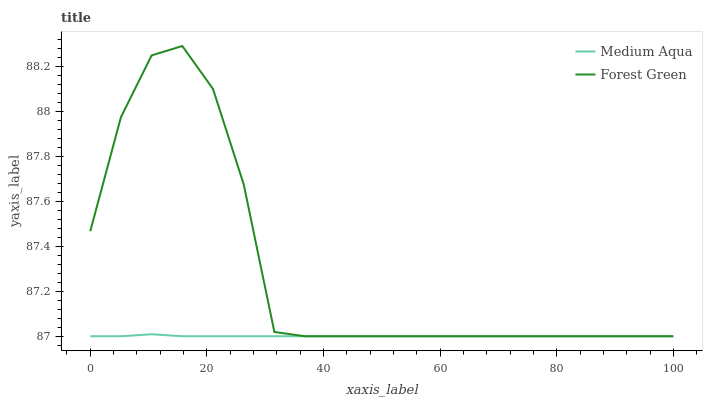Does Medium Aqua have the minimum area under the curve?
Answer yes or no. Yes. Does Forest Green have the maximum area under the curve?
Answer yes or no. Yes. Does Medium Aqua have the maximum area under the curve?
Answer yes or no. No. Is Medium Aqua the smoothest?
Answer yes or no. Yes. Is Forest Green the roughest?
Answer yes or no. Yes. Is Medium Aqua the roughest?
Answer yes or no. No. Does Forest Green have the highest value?
Answer yes or no. Yes. Does Medium Aqua have the highest value?
Answer yes or no. No. Does Forest Green intersect Medium Aqua?
Answer yes or no. Yes. Is Forest Green less than Medium Aqua?
Answer yes or no. No. Is Forest Green greater than Medium Aqua?
Answer yes or no. No. 